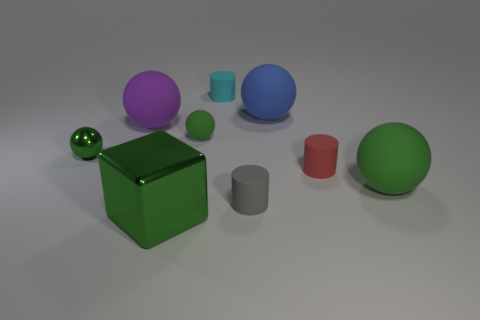The red cylinder that is made of the same material as the big blue sphere is what size?
Make the answer very short. Small. How many things are red matte objects or blue things?
Offer a terse response. 2. The big ball left of the big blue thing is what color?
Ensure brevity in your answer.  Purple. There is a gray rubber object that is the same shape as the cyan thing; what is its size?
Make the answer very short. Small. What number of objects are either tiny things to the right of the purple matte thing or rubber balls behind the tiny red thing?
Your answer should be very brief. 6. There is a green ball that is both left of the gray matte cylinder and to the right of the metal ball; what size is it?
Provide a succinct answer. Small. Do the small cyan object and the metal thing to the left of the purple thing have the same shape?
Ensure brevity in your answer.  No. How many objects are either tiny green spheres behind the metal ball or tiny red objects?
Provide a short and direct response. 2. Do the cyan object and the green ball to the left of the purple rubber object have the same material?
Provide a short and direct response. No. The small matte thing that is left of the tiny object that is behind the blue object is what shape?
Your response must be concise. Sphere. 